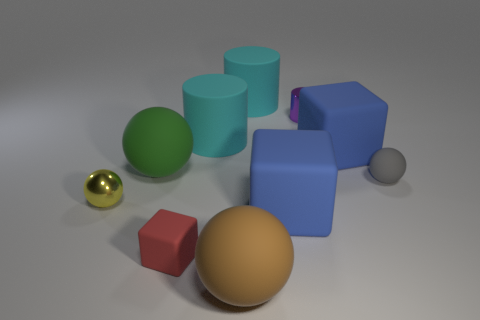Is the material of the red cube the same as the blue block that is on the right side of the purple metal cylinder?
Offer a terse response. Yes. Is the number of large matte cylinders less than the number of large yellow balls?
Keep it short and to the point. No. Are there any other things of the same color as the tiny matte cube?
Keep it short and to the point. No. What is the shape of the small object that is the same material as the small yellow sphere?
Provide a short and direct response. Cylinder. There is a cyan rubber thing that is on the right side of the cyan cylinder left of the brown matte object; what number of green spheres are behind it?
Your response must be concise. 0. The thing that is in front of the large green object and to the left of the tiny red matte block has what shape?
Offer a terse response. Sphere. Is the number of large blocks that are left of the small rubber block less than the number of small red things?
Provide a succinct answer. Yes. How many large objects are gray rubber things or red metal cubes?
Make the answer very short. 0. The red object has what size?
Offer a terse response. Small. Is there anything else that has the same material as the brown ball?
Offer a terse response. Yes. 